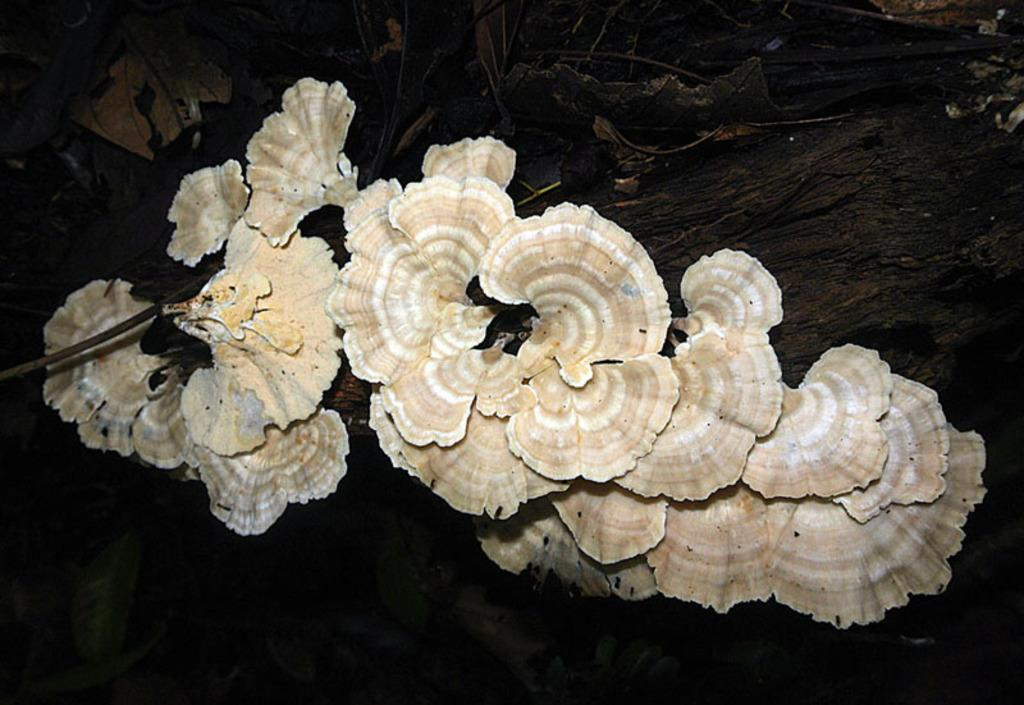What type of growth can be seen on a tree in the image? There is fungus on a tree in the image. What can be seen in the background of the image? There are leaves visible in the background of the image. How would you describe the quality of the image? The image is not clear. What position does the fungus hold in the image? The fungus does not hold a position in the image; it is a growth on a tree. How does the fungus attract the attention of the viewer in the image? The fungus does not attract the attention of the viewer in the image; it is just one element among others. 